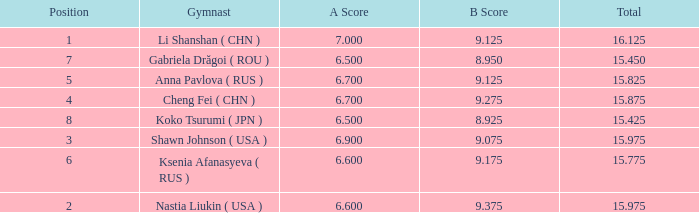What's the total that the position is less than 1? None. 